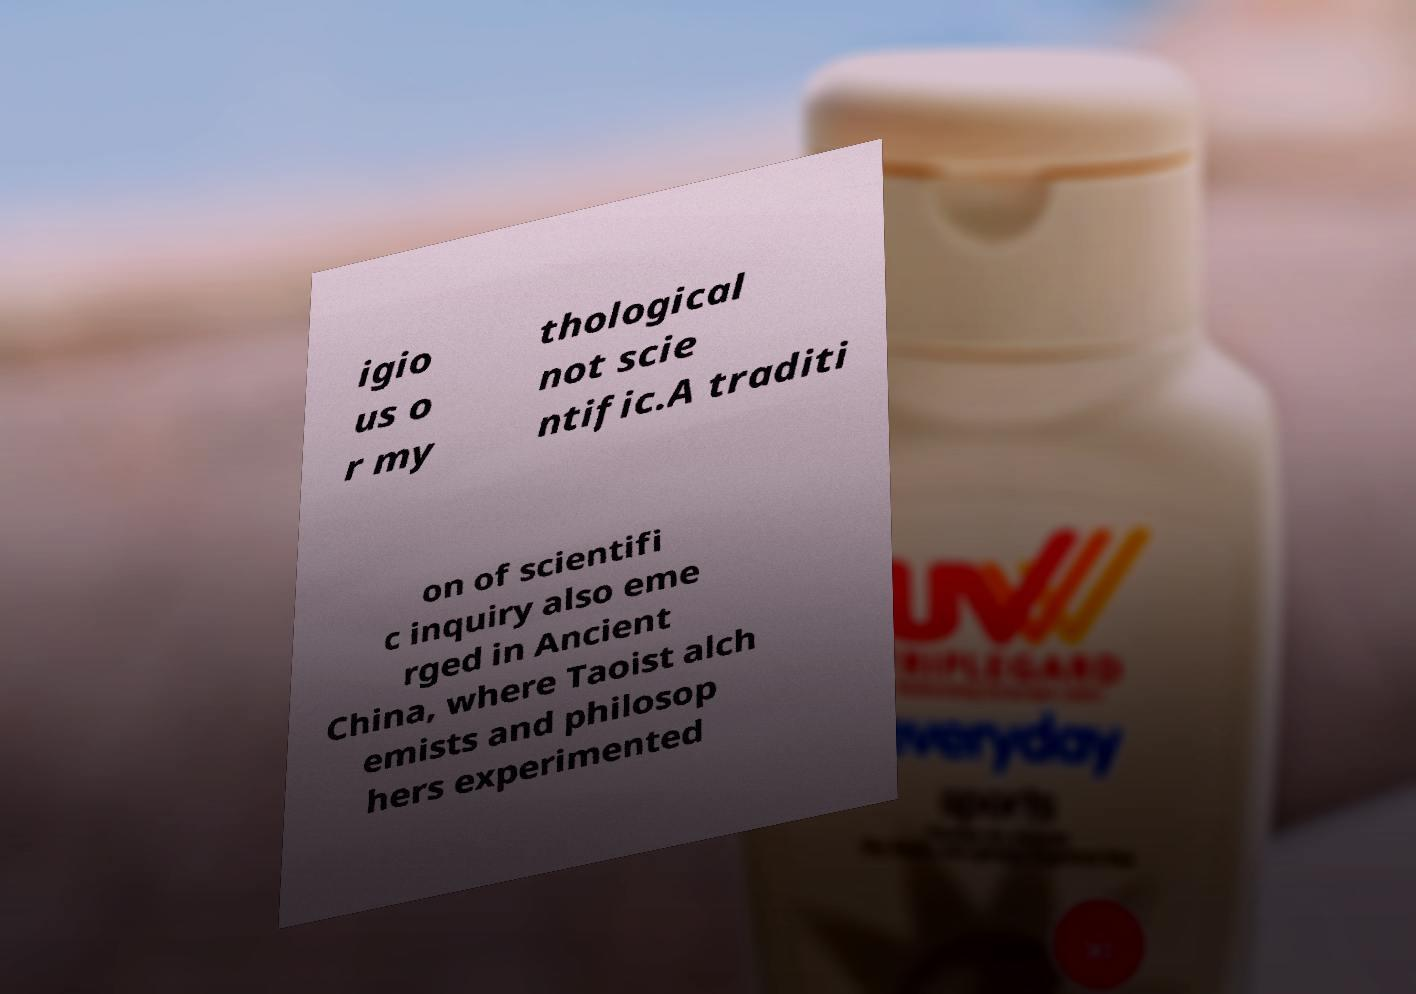Could you extract and type out the text from this image? igio us o r my thological not scie ntific.A traditi on of scientifi c inquiry also eme rged in Ancient China, where Taoist alch emists and philosop hers experimented 